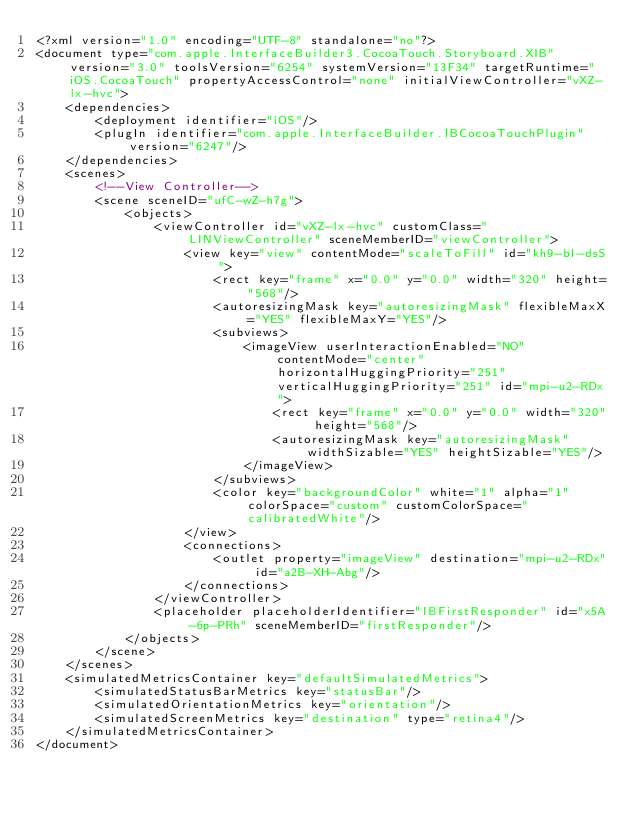<code> <loc_0><loc_0><loc_500><loc_500><_XML_><?xml version="1.0" encoding="UTF-8" standalone="no"?>
<document type="com.apple.InterfaceBuilder3.CocoaTouch.Storyboard.XIB" version="3.0" toolsVersion="6254" systemVersion="13F34" targetRuntime="iOS.CocoaTouch" propertyAccessControl="none" initialViewController="vXZ-lx-hvc">
    <dependencies>
        <deployment identifier="iOS"/>
        <plugIn identifier="com.apple.InterfaceBuilder.IBCocoaTouchPlugin" version="6247"/>
    </dependencies>
    <scenes>
        <!--View Controller-->
        <scene sceneID="ufC-wZ-h7g">
            <objects>
                <viewController id="vXZ-lx-hvc" customClass="LINViewController" sceneMemberID="viewController">
                    <view key="view" contentMode="scaleToFill" id="kh9-bI-dsS">
                        <rect key="frame" x="0.0" y="0.0" width="320" height="568"/>
                        <autoresizingMask key="autoresizingMask" flexibleMaxX="YES" flexibleMaxY="YES"/>
                        <subviews>
                            <imageView userInteractionEnabled="NO" contentMode="center" horizontalHuggingPriority="251" verticalHuggingPriority="251" id="mpi-u2-RDx">
                                <rect key="frame" x="0.0" y="0.0" width="320" height="568"/>
                                <autoresizingMask key="autoresizingMask" widthSizable="YES" heightSizable="YES"/>
                            </imageView>
                        </subviews>
                        <color key="backgroundColor" white="1" alpha="1" colorSpace="custom" customColorSpace="calibratedWhite"/>
                    </view>
                    <connections>
                        <outlet property="imageView" destination="mpi-u2-RDx" id="a2B-XH-Abg"/>
                    </connections>
                </viewController>
                <placeholder placeholderIdentifier="IBFirstResponder" id="x5A-6p-PRh" sceneMemberID="firstResponder"/>
            </objects>
        </scene>
    </scenes>
    <simulatedMetricsContainer key="defaultSimulatedMetrics">
        <simulatedStatusBarMetrics key="statusBar"/>
        <simulatedOrientationMetrics key="orientation"/>
        <simulatedScreenMetrics key="destination" type="retina4"/>
    </simulatedMetricsContainer>
</document>
</code> 